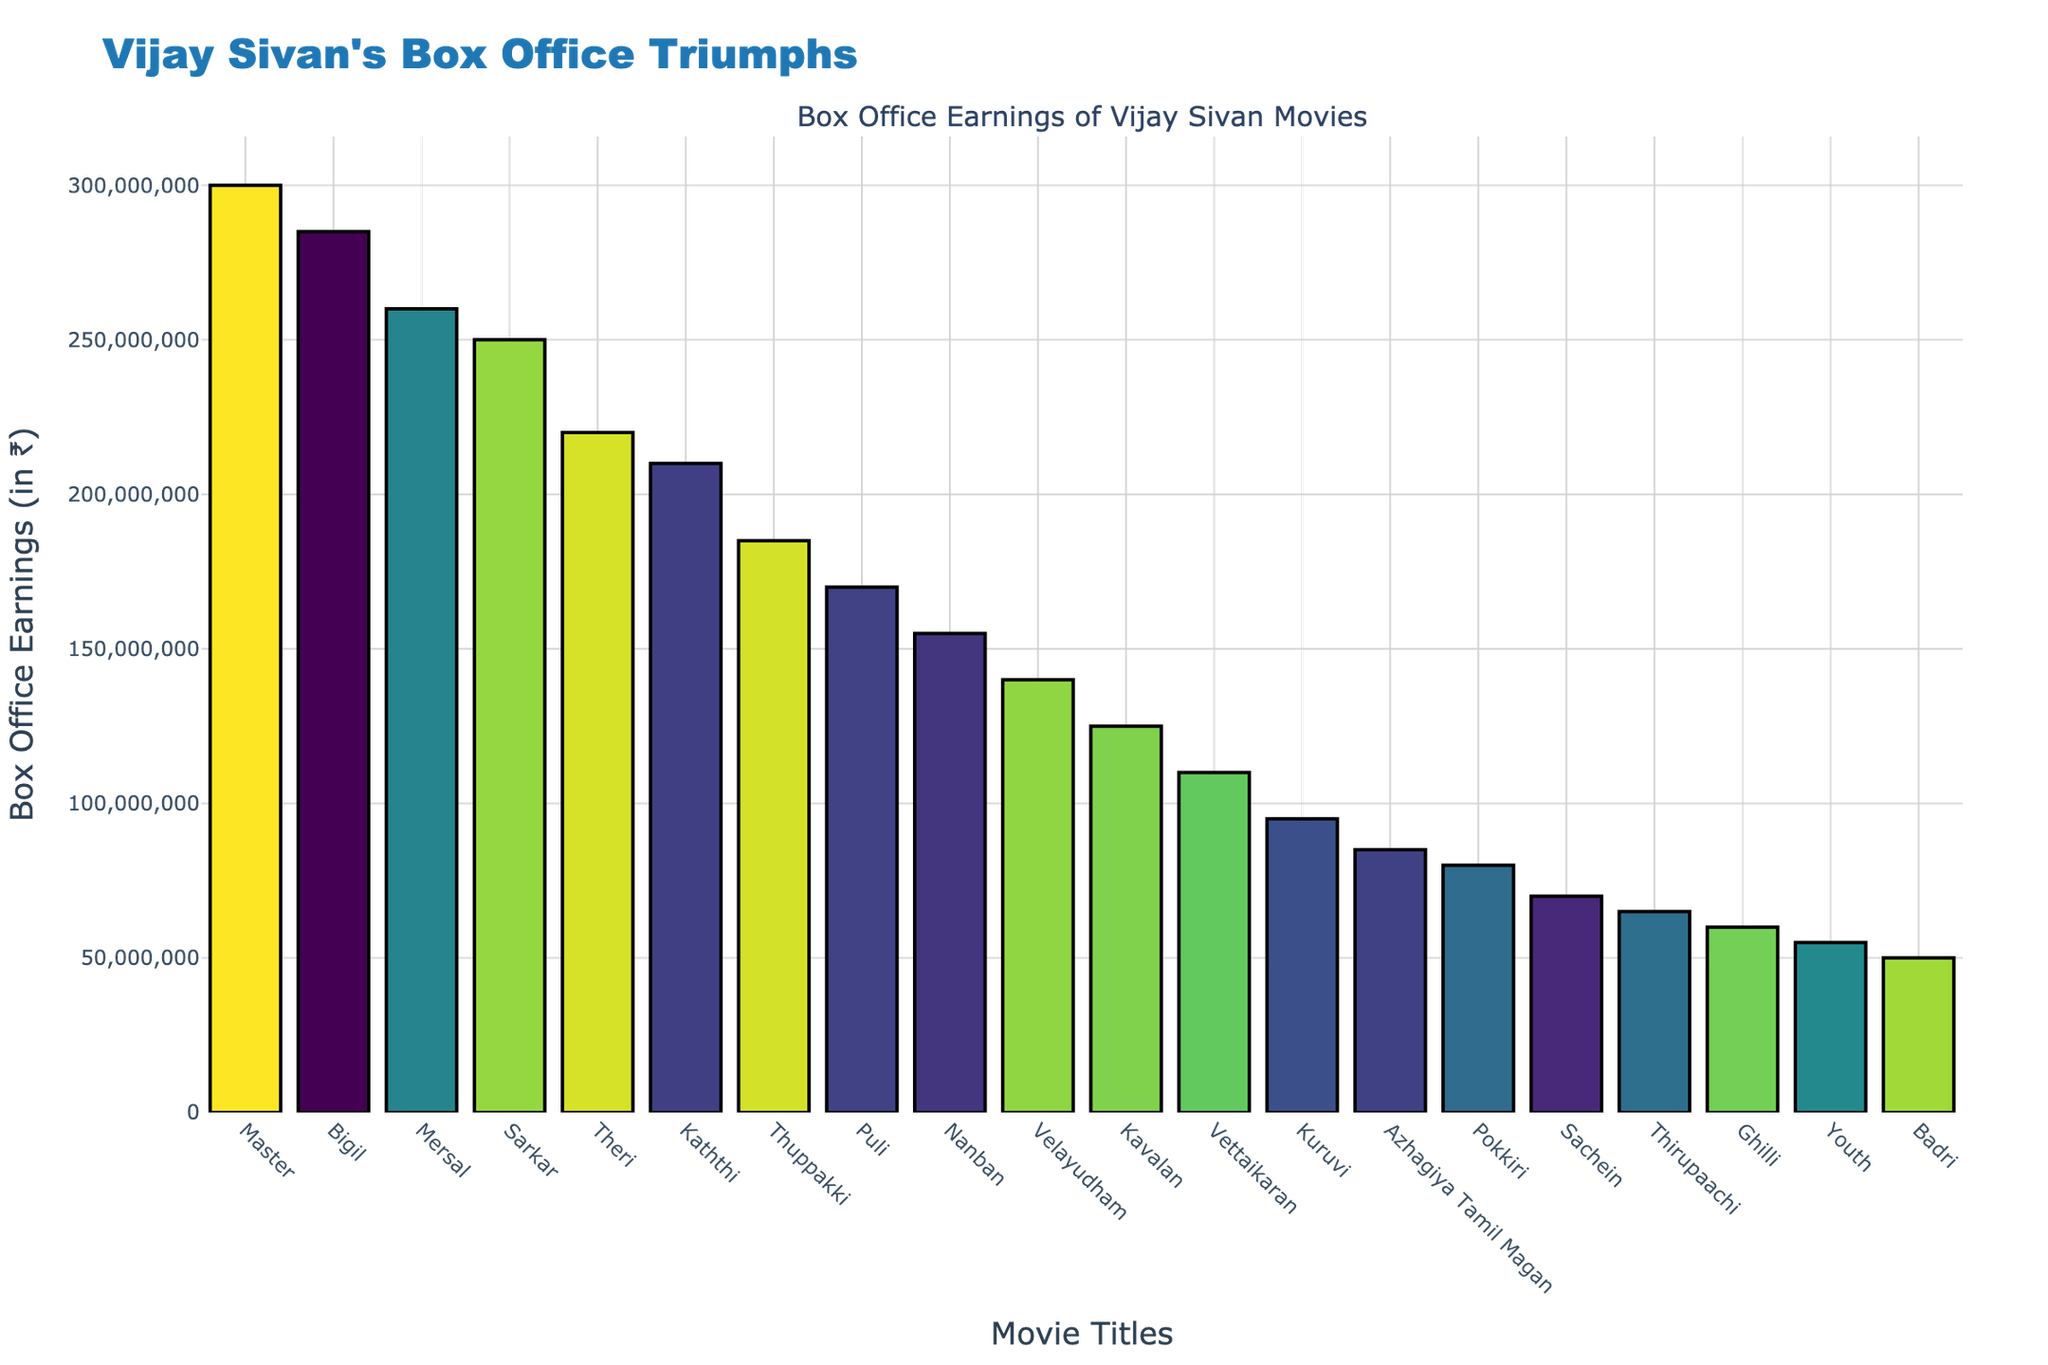What's the highest box office earning for a Vijay Sivan movie? The highest box office earning is represented by the tallest bar in the figure. The movie "Master" has the tallest bar with earnings of ₹300,000,000.
Answer: ₹300,000,000 Which Vijay Sivan movie has the second-highest box office earnings? The second-highest bar in the figure represents the second-highest box office earnings. The movie "Bigil" has the second-highest earnings of ₹285,000,000.
Answer: Bigil What is the difference in box office earnings between "Master" and "Kaththi"? Find the earnings for both movies and subtract Kaththi's earnings from Master's earnings (₹300,000,000 - ₹210,000,000).
Answer: ₹90,000,000 Which movie has higher box office earnings, "Theri" or "Mersal"? Compare the heights of the bars for "Theri" and "Mersal". "Mersal" has higher earnings with ₹260,000,000 compared to "Theri" with ₹220,000,000.
Answer: Mersal What's the average box office earnings of the top three movies? Sum the earnings of the top three movies and divide by 3. (₹300,000,000 + ₹285,000,000 + ₹260,000,000) / 3 = ₹281,666,667.
Answer: ₹281,666,667 What is the total box office earnings of the bottom three movies? Sum the earnings of the bottom three movies based on the ranked order. (₹55,000,000 + ₹50,000,000 + ₹60,000,000) = ₹165,000,000.
Answer: ₹165,000,000 How many movies earned more than ₹200,000,000? Count the number of bars that exceed the ₹200,000,000 mark. There are five such movies: "Master", "Bigil", "Mersal", "Sarkar", and "Theri".
Answer: 5 Between "Nanban" and "Velayudham," which movie earned less? Compare the heights of the bars for "Nanban" and "Velayudham". "Velayudham" earned less with ₹140,000,000 compared to "Nanban" with ₹155,000,000.
Answer: Velayudham Which movie has earnings closest to ₹150,000,000? Look for the bar that is closest to the ₹150,000,000 mark. "Nanban" has earnings closest to ₹150,000,000 with ₹155,000,000.
Answer: Nanban 